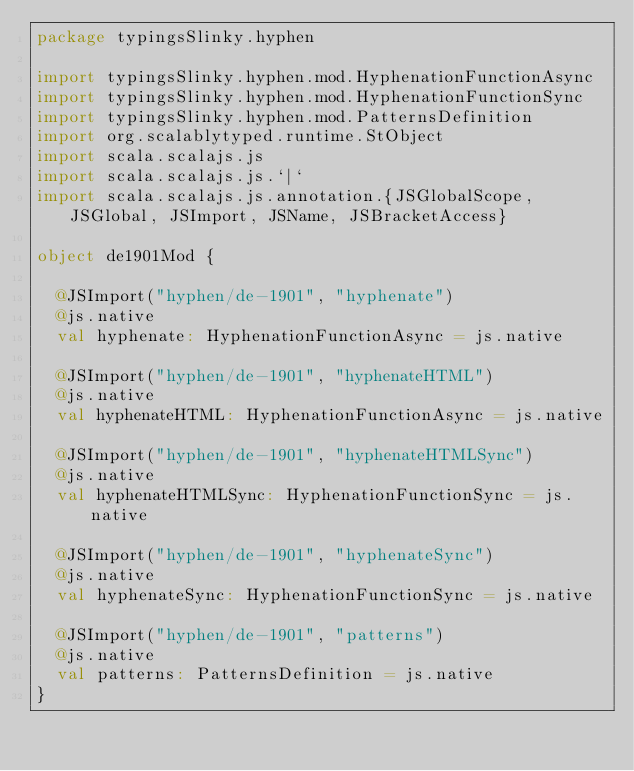Convert code to text. <code><loc_0><loc_0><loc_500><loc_500><_Scala_>package typingsSlinky.hyphen

import typingsSlinky.hyphen.mod.HyphenationFunctionAsync
import typingsSlinky.hyphen.mod.HyphenationFunctionSync
import typingsSlinky.hyphen.mod.PatternsDefinition
import org.scalablytyped.runtime.StObject
import scala.scalajs.js
import scala.scalajs.js.`|`
import scala.scalajs.js.annotation.{JSGlobalScope, JSGlobal, JSImport, JSName, JSBracketAccess}

object de1901Mod {
  
  @JSImport("hyphen/de-1901", "hyphenate")
  @js.native
  val hyphenate: HyphenationFunctionAsync = js.native
  
  @JSImport("hyphen/de-1901", "hyphenateHTML")
  @js.native
  val hyphenateHTML: HyphenationFunctionAsync = js.native
  
  @JSImport("hyphen/de-1901", "hyphenateHTMLSync")
  @js.native
  val hyphenateHTMLSync: HyphenationFunctionSync = js.native
  
  @JSImport("hyphen/de-1901", "hyphenateSync")
  @js.native
  val hyphenateSync: HyphenationFunctionSync = js.native
  
  @JSImport("hyphen/de-1901", "patterns")
  @js.native
  val patterns: PatternsDefinition = js.native
}
</code> 